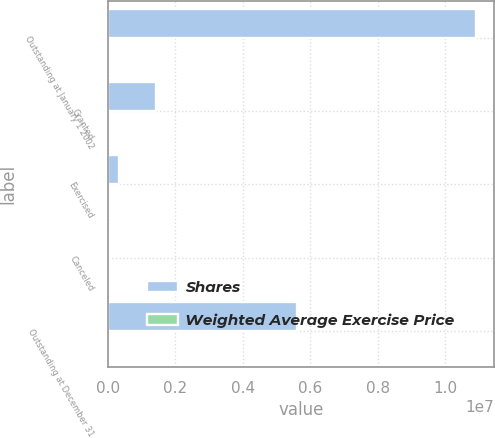<chart> <loc_0><loc_0><loc_500><loc_500><stacked_bar_chart><ecel><fcel>Outstanding at January 1 2002<fcel>Granted<fcel>Exercised<fcel>Canceled<fcel>Outstanding at December 31<nl><fcel>Shares<fcel>1.09076e+07<fcel>1.423e+06<fcel>329704<fcel>38509<fcel>5.59987e+06<nl><fcel>Weighted Average Exercise Price<fcel>34.28<fcel>37.73<fcel>30.28<fcel>37.13<fcel>38.08<nl></chart> 